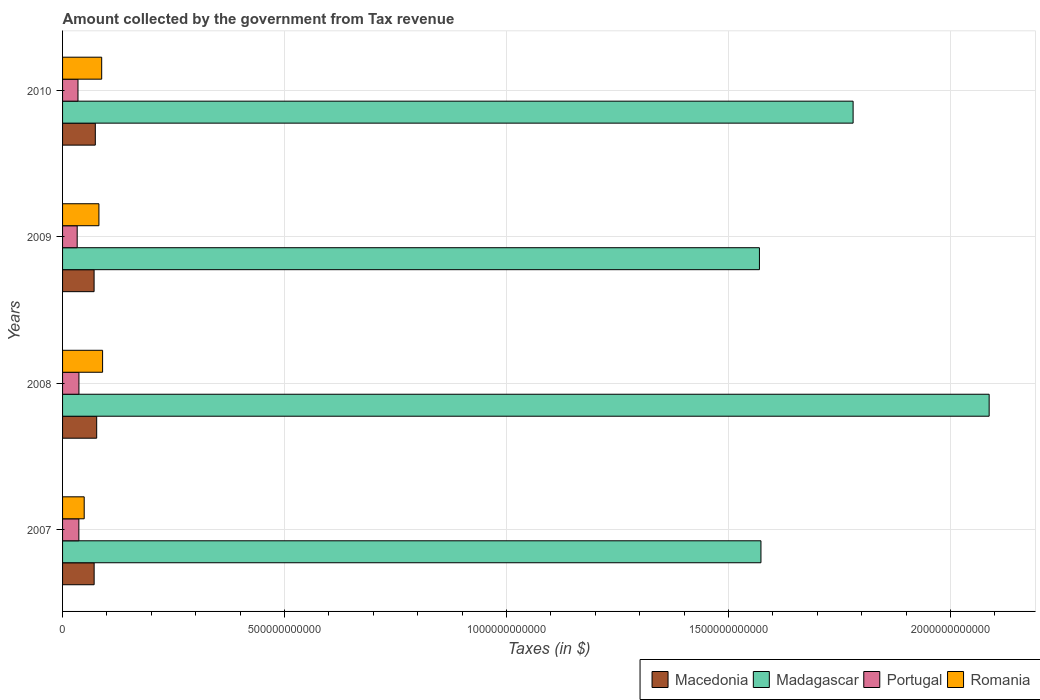How many groups of bars are there?
Give a very brief answer. 4. What is the label of the 3rd group of bars from the top?
Provide a succinct answer. 2008. In how many cases, is the number of bars for a given year not equal to the number of legend labels?
Offer a very short reply. 0. What is the amount collected by the government from tax revenue in Madagascar in 2010?
Your response must be concise. 1.78e+12. Across all years, what is the maximum amount collected by the government from tax revenue in Macedonia?
Provide a succinct answer. 7.69e+1. Across all years, what is the minimum amount collected by the government from tax revenue in Macedonia?
Give a very brief answer. 7.10e+1. In which year was the amount collected by the government from tax revenue in Madagascar maximum?
Your response must be concise. 2008. In which year was the amount collected by the government from tax revenue in Madagascar minimum?
Your answer should be very brief. 2009. What is the total amount collected by the government from tax revenue in Macedonia in the graph?
Offer a very short reply. 2.93e+11. What is the difference between the amount collected by the government from tax revenue in Romania in 2009 and that in 2010?
Your response must be concise. -6.22e+09. What is the difference between the amount collected by the government from tax revenue in Macedonia in 2010 and the amount collected by the government from tax revenue in Madagascar in 2009?
Your answer should be very brief. -1.50e+12. What is the average amount collected by the government from tax revenue in Portugal per year?
Your answer should be very brief. 3.53e+1. In the year 2010, what is the difference between the amount collected by the government from tax revenue in Romania and amount collected by the government from tax revenue in Macedonia?
Your answer should be very brief. 1.44e+1. In how many years, is the amount collected by the government from tax revenue in Romania greater than 100000000000 $?
Your response must be concise. 0. What is the ratio of the amount collected by the government from tax revenue in Macedonia in 2007 to that in 2009?
Give a very brief answer. 1. What is the difference between the highest and the second highest amount collected by the government from tax revenue in Madagascar?
Ensure brevity in your answer.  3.06e+11. What is the difference between the highest and the lowest amount collected by the government from tax revenue in Romania?
Provide a short and direct response. 4.14e+1. What does the 2nd bar from the top in 2007 represents?
Offer a terse response. Portugal. What does the 2nd bar from the bottom in 2010 represents?
Provide a short and direct response. Madagascar. Is it the case that in every year, the sum of the amount collected by the government from tax revenue in Portugal and amount collected by the government from tax revenue in Macedonia is greater than the amount collected by the government from tax revenue in Madagascar?
Ensure brevity in your answer.  No. Are all the bars in the graph horizontal?
Your answer should be very brief. Yes. What is the difference between two consecutive major ticks on the X-axis?
Ensure brevity in your answer.  5.00e+11. Are the values on the major ticks of X-axis written in scientific E-notation?
Your answer should be very brief. No. Does the graph contain grids?
Offer a very short reply. Yes. Where does the legend appear in the graph?
Your answer should be very brief. Bottom right. How are the legend labels stacked?
Provide a short and direct response. Horizontal. What is the title of the graph?
Make the answer very short. Amount collected by the government from Tax revenue. What is the label or title of the X-axis?
Your answer should be compact. Taxes (in $). What is the Taxes (in $) of Macedonia in 2007?
Your answer should be very brief. 7.11e+1. What is the Taxes (in $) of Madagascar in 2007?
Give a very brief answer. 1.57e+12. What is the Taxes (in $) in Portugal in 2007?
Your answer should be compact. 3.67e+1. What is the Taxes (in $) of Romania in 2007?
Ensure brevity in your answer.  4.88e+1. What is the Taxes (in $) in Macedonia in 2008?
Give a very brief answer. 7.69e+1. What is the Taxes (in $) of Madagascar in 2008?
Your answer should be very brief. 2.09e+12. What is the Taxes (in $) in Portugal in 2008?
Your response must be concise. 3.69e+1. What is the Taxes (in $) in Romania in 2008?
Make the answer very short. 9.01e+1. What is the Taxes (in $) in Macedonia in 2009?
Ensure brevity in your answer.  7.10e+1. What is the Taxes (in $) in Madagascar in 2009?
Offer a terse response. 1.57e+12. What is the Taxes (in $) in Portugal in 2009?
Offer a terse response. 3.30e+1. What is the Taxes (in $) in Romania in 2009?
Offer a very short reply. 8.19e+1. What is the Taxes (in $) of Macedonia in 2010?
Make the answer very short. 7.38e+1. What is the Taxes (in $) in Madagascar in 2010?
Ensure brevity in your answer.  1.78e+12. What is the Taxes (in $) in Portugal in 2010?
Provide a short and direct response. 3.47e+1. What is the Taxes (in $) in Romania in 2010?
Offer a very short reply. 8.81e+1. Across all years, what is the maximum Taxes (in $) in Macedonia?
Offer a very short reply. 7.69e+1. Across all years, what is the maximum Taxes (in $) in Madagascar?
Provide a short and direct response. 2.09e+12. Across all years, what is the maximum Taxes (in $) of Portugal?
Make the answer very short. 3.69e+1. Across all years, what is the maximum Taxes (in $) of Romania?
Your answer should be very brief. 9.01e+1. Across all years, what is the minimum Taxes (in $) in Macedonia?
Give a very brief answer. 7.10e+1. Across all years, what is the minimum Taxes (in $) in Madagascar?
Provide a succinct answer. 1.57e+12. Across all years, what is the minimum Taxes (in $) of Portugal?
Ensure brevity in your answer.  3.30e+1. Across all years, what is the minimum Taxes (in $) in Romania?
Provide a short and direct response. 4.88e+1. What is the total Taxes (in $) in Macedonia in the graph?
Make the answer very short. 2.93e+11. What is the total Taxes (in $) in Madagascar in the graph?
Provide a succinct answer. 7.01e+12. What is the total Taxes (in $) in Portugal in the graph?
Give a very brief answer. 1.41e+11. What is the total Taxes (in $) in Romania in the graph?
Your answer should be very brief. 3.09e+11. What is the difference between the Taxes (in $) of Macedonia in 2007 and that in 2008?
Provide a short and direct response. -5.73e+09. What is the difference between the Taxes (in $) in Madagascar in 2007 and that in 2008?
Your answer should be very brief. -5.14e+11. What is the difference between the Taxes (in $) of Portugal in 2007 and that in 2008?
Provide a short and direct response. -1.94e+08. What is the difference between the Taxes (in $) in Romania in 2007 and that in 2008?
Offer a terse response. -4.14e+1. What is the difference between the Taxes (in $) of Macedonia in 2007 and that in 2009?
Offer a very short reply. 1.05e+08. What is the difference between the Taxes (in $) in Madagascar in 2007 and that in 2009?
Your response must be concise. 3.39e+09. What is the difference between the Taxes (in $) in Portugal in 2007 and that in 2009?
Your answer should be very brief. 3.73e+09. What is the difference between the Taxes (in $) of Romania in 2007 and that in 2009?
Provide a short and direct response. -3.31e+1. What is the difference between the Taxes (in $) in Macedonia in 2007 and that in 2010?
Make the answer very short. -2.63e+09. What is the difference between the Taxes (in $) of Madagascar in 2007 and that in 2010?
Your answer should be very brief. -2.08e+11. What is the difference between the Taxes (in $) of Portugal in 2007 and that in 2010?
Offer a terse response. 1.97e+09. What is the difference between the Taxes (in $) in Romania in 2007 and that in 2010?
Your answer should be compact. -3.94e+1. What is the difference between the Taxes (in $) of Macedonia in 2008 and that in 2009?
Your response must be concise. 5.83e+09. What is the difference between the Taxes (in $) in Madagascar in 2008 and that in 2009?
Ensure brevity in your answer.  5.17e+11. What is the difference between the Taxes (in $) of Portugal in 2008 and that in 2009?
Your answer should be very brief. 3.93e+09. What is the difference between the Taxes (in $) in Romania in 2008 and that in 2009?
Give a very brief answer. 8.26e+09. What is the difference between the Taxes (in $) in Macedonia in 2008 and that in 2010?
Keep it short and to the point. 3.10e+09. What is the difference between the Taxes (in $) of Madagascar in 2008 and that in 2010?
Your response must be concise. 3.06e+11. What is the difference between the Taxes (in $) of Portugal in 2008 and that in 2010?
Give a very brief answer. 2.16e+09. What is the difference between the Taxes (in $) in Romania in 2008 and that in 2010?
Your answer should be compact. 2.04e+09. What is the difference between the Taxes (in $) of Macedonia in 2009 and that in 2010?
Your answer should be compact. -2.73e+09. What is the difference between the Taxes (in $) of Madagascar in 2009 and that in 2010?
Offer a very short reply. -2.11e+11. What is the difference between the Taxes (in $) of Portugal in 2009 and that in 2010?
Your answer should be compact. -1.77e+09. What is the difference between the Taxes (in $) of Romania in 2009 and that in 2010?
Make the answer very short. -6.22e+09. What is the difference between the Taxes (in $) of Macedonia in 2007 and the Taxes (in $) of Madagascar in 2008?
Keep it short and to the point. -2.02e+12. What is the difference between the Taxes (in $) in Macedonia in 2007 and the Taxes (in $) in Portugal in 2008?
Keep it short and to the point. 3.42e+1. What is the difference between the Taxes (in $) in Macedonia in 2007 and the Taxes (in $) in Romania in 2008?
Provide a succinct answer. -1.90e+1. What is the difference between the Taxes (in $) in Madagascar in 2007 and the Taxes (in $) in Portugal in 2008?
Provide a short and direct response. 1.54e+12. What is the difference between the Taxes (in $) in Madagascar in 2007 and the Taxes (in $) in Romania in 2008?
Ensure brevity in your answer.  1.48e+12. What is the difference between the Taxes (in $) of Portugal in 2007 and the Taxes (in $) of Romania in 2008?
Ensure brevity in your answer.  -5.35e+1. What is the difference between the Taxes (in $) of Macedonia in 2007 and the Taxes (in $) of Madagascar in 2009?
Make the answer very short. -1.50e+12. What is the difference between the Taxes (in $) in Macedonia in 2007 and the Taxes (in $) in Portugal in 2009?
Your answer should be very brief. 3.82e+1. What is the difference between the Taxes (in $) in Macedonia in 2007 and the Taxes (in $) in Romania in 2009?
Offer a very short reply. -1.08e+1. What is the difference between the Taxes (in $) of Madagascar in 2007 and the Taxes (in $) of Portugal in 2009?
Offer a very short reply. 1.54e+12. What is the difference between the Taxes (in $) of Madagascar in 2007 and the Taxes (in $) of Romania in 2009?
Offer a very short reply. 1.49e+12. What is the difference between the Taxes (in $) of Portugal in 2007 and the Taxes (in $) of Romania in 2009?
Your answer should be very brief. -4.52e+1. What is the difference between the Taxes (in $) of Macedonia in 2007 and the Taxes (in $) of Madagascar in 2010?
Keep it short and to the point. -1.71e+12. What is the difference between the Taxes (in $) in Macedonia in 2007 and the Taxes (in $) in Portugal in 2010?
Offer a terse response. 3.64e+1. What is the difference between the Taxes (in $) of Macedonia in 2007 and the Taxes (in $) of Romania in 2010?
Your answer should be compact. -1.70e+1. What is the difference between the Taxes (in $) in Madagascar in 2007 and the Taxes (in $) in Portugal in 2010?
Your answer should be compact. 1.54e+12. What is the difference between the Taxes (in $) in Madagascar in 2007 and the Taxes (in $) in Romania in 2010?
Your answer should be compact. 1.49e+12. What is the difference between the Taxes (in $) in Portugal in 2007 and the Taxes (in $) in Romania in 2010?
Provide a succinct answer. -5.14e+1. What is the difference between the Taxes (in $) in Macedonia in 2008 and the Taxes (in $) in Madagascar in 2009?
Your answer should be compact. -1.49e+12. What is the difference between the Taxes (in $) of Macedonia in 2008 and the Taxes (in $) of Portugal in 2009?
Offer a very short reply. 4.39e+1. What is the difference between the Taxes (in $) of Macedonia in 2008 and the Taxes (in $) of Romania in 2009?
Provide a succinct answer. -5.03e+09. What is the difference between the Taxes (in $) in Madagascar in 2008 and the Taxes (in $) in Portugal in 2009?
Give a very brief answer. 2.05e+12. What is the difference between the Taxes (in $) of Madagascar in 2008 and the Taxes (in $) of Romania in 2009?
Your answer should be very brief. 2.01e+12. What is the difference between the Taxes (in $) of Portugal in 2008 and the Taxes (in $) of Romania in 2009?
Provide a short and direct response. -4.50e+1. What is the difference between the Taxes (in $) in Macedonia in 2008 and the Taxes (in $) in Madagascar in 2010?
Provide a succinct answer. -1.70e+12. What is the difference between the Taxes (in $) of Macedonia in 2008 and the Taxes (in $) of Portugal in 2010?
Give a very brief answer. 4.21e+1. What is the difference between the Taxes (in $) of Macedonia in 2008 and the Taxes (in $) of Romania in 2010?
Offer a very short reply. -1.13e+1. What is the difference between the Taxes (in $) of Madagascar in 2008 and the Taxes (in $) of Portugal in 2010?
Give a very brief answer. 2.05e+12. What is the difference between the Taxes (in $) of Madagascar in 2008 and the Taxes (in $) of Romania in 2010?
Your answer should be very brief. 2.00e+12. What is the difference between the Taxes (in $) of Portugal in 2008 and the Taxes (in $) of Romania in 2010?
Provide a short and direct response. -5.12e+1. What is the difference between the Taxes (in $) in Macedonia in 2009 and the Taxes (in $) in Madagascar in 2010?
Offer a terse response. -1.71e+12. What is the difference between the Taxes (in $) of Macedonia in 2009 and the Taxes (in $) of Portugal in 2010?
Provide a succinct answer. 3.63e+1. What is the difference between the Taxes (in $) of Macedonia in 2009 and the Taxes (in $) of Romania in 2010?
Your answer should be compact. -1.71e+1. What is the difference between the Taxes (in $) of Madagascar in 2009 and the Taxes (in $) of Portugal in 2010?
Your answer should be very brief. 1.54e+12. What is the difference between the Taxes (in $) in Madagascar in 2009 and the Taxes (in $) in Romania in 2010?
Make the answer very short. 1.48e+12. What is the difference between the Taxes (in $) in Portugal in 2009 and the Taxes (in $) in Romania in 2010?
Offer a very short reply. -5.52e+1. What is the average Taxes (in $) of Macedonia per year?
Make the answer very short. 7.32e+1. What is the average Taxes (in $) in Madagascar per year?
Keep it short and to the point. 1.75e+12. What is the average Taxes (in $) of Portugal per year?
Provide a succinct answer. 3.53e+1. What is the average Taxes (in $) of Romania per year?
Make the answer very short. 7.72e+1. In the year 2007, what is the difference between the Taxes (in $) of Macedonia and Taxes (in $) of Madagascar?
Provide a short and direct response. -1.50e+12. In the year 2007, what is the difference between the Taxes (in $) in Macedonia and Taxes (in $) in Portugal?
Keep it short and to the point. 3.44e+1. In the year 2007, what is the difference between the Taxes (in $) in Macedonia and Taxes (in $) in Romania?
Ensure brevity in your answer.  2.24e+1. In the year 2007, what is the difference between the Taxes (in $) of Madagascar and Taxes (in $) of Portugal?
Make the answer very short. 1.54e+12. In the year 2007, what is the difference between the Taxes (in $) in Madagascar and Taxes (in $) in Romania?
Ensure brevity in your answer.  1.52e+12. In the year 2007, what is the difference between the Taxes (in $) in Portugal and Taxes (in $) in Romania?
Your response must be concise. -1.21e+1. In the year 2008, what is the difference between the Taxes (in $) in Macedonia and Taxes (in $) in Madagascar?
Provide a succinct answer. -2.01e+12. In the year 2008, what is the difference between the Taxes (in $) of Macedonia and Taxes (in $) of Portugal?
Keep it short and to the point. 4.00e+1. In the year 2008, what is the difference between the Taxes (in $) in Macedonia and Taxes (in $) in Romania?
Your answer should be very brief. -1.33e+1. In the year 2008, what is the difference between the Taxes (in $) of Madagascar and Taxes (in $) of Portugal?
Your answer should be very brief. 2.05e+12. In the year 2008, what is the difference between the Taxes (in $) of Madagascar and Taxes (in $) of Romania?
Make the answer very short. 2.00e+12. In the year 2008, what is the difference between the Taxes (in $) in Portugal and Taxes (in $) in Romania?
Your answer should be compact. -5.33e+1. In the year 2009, what is the difference between the Taxes (in $) in Macedonia and Taxes (in $) in Madagascar?
Offer a terse response. -1.50e+12. In the year 2009, what is the difference between the Taxes (in $) of Macedonia and Taxes (in $) of Portugal?
Give a very brief answer. 3.81e+1. In the year 2009, what is the difference between the Taxes (in $) of Macedonia and Taxes (in $) of Romania?
Offer a very short reply. -1.09e+1. In the year 2009, what is the difference between the Taxes (in $) of Madagascar and Taxes (in $) of Portugal?
Give a very brief answer. 1.54e+12. In the year 2009, what is the difference between the Taxes (in $) in Madagascar and Taxes (in $) in Romania?
Your answer should be very brief. 1.49e+12. In the year 2009, what is the difference between the Taxes (in $) in Portugal and Taxes (in $) in Romania?
Offer a terse response. -4.89e+1. In the year 2010, what is the difference between the Taxes (in $) in Macedonia and Taxes (in $) in Madagascar?
Offer a very short reply. -1.71e+12. In the year 2010, what is the difference between the Taxes (in $) in Macedonia and Taxes (in $) in Portugal?
Give a very brief answer. 3.90e+1. In the year 2010, what is the difference between the Taxes (in $) in Macedonia and Taxes (in $) in Romania?
Offer a very short reply. -1.44e+1. In the year 2010, what is the difference between the Taxes (in $) of Madagascar and Taxes (in $) of Portugal?
Provide a short and direct response. 1.75e+12. In the year 2010, what is the difference between the Taxes (in $) in Madagascar and Taxes (in $) in Romania?
Ensure brevity in your answer.  1.69e+12. In the year 2010, what is the difference between the Taxes (in $) of Portugal and Taxes (in $) of Romania?
Keep it short and to the point. -5.34e+1. What is the ratio of the Taxes (in $) of Macedonia in 2007 to that in 2008?
Give a very brief answer. 0.93. What is the ratio of the Taxes (in $) of Madagascar in 2007 to that in 2008?
Provide a succinct answer. 0.75. What is the ratio of the Taxes (in $) in Portugal in 2007 to that in 2008?
Provide a short and direct response. 0.99. What is the ratio of the Taxes (in $) of Romania in 2007 to that in 2008?
Keep it short and to the point. 0.54. What is the ratio of the Taxes (in $) in Portugal in 2007 to that in 2009?
Ensure brevity in your answer.  1.11. What is the ratio of the Taxes (in $) of Romania in 2007 to that in 2009?
Make the answer very short. 0.6. What is the ratio of the Taxes (in $) in Macedonia in 2007 to that in 2010?
Provide a succinct answer. 0.96. What is the ratio of the Taxes (in $) of Madagascar in 2007 to that in 2010?
Provide a short and direct response. 0.88. What is the ratio of the Taxes (in $) in Portugal in 2007 to that in 2010?
Your response must be concise. 1.06. What is the ratio of the Taxes (in $) in Romania in 2007 to that in 2010?
Ensure brevity in your answer.  0.55. What is the ratio of the Taxes (in $) in Macedonia in 2008 to that in 2009?
Your response must be concise. 1.08. What is the ratio of the Taxes (in $) in Madagascar in 2008 to that in 2009?
Offer a very short reply. 1.33. What is the ratio of the Taxes (in $) of Portugal in 2008 to that in 2009?
Give a very brief answer. 1.12. What is the ratio of the Taxes (in $) of Romania in 2008 to that in 2009?
Ensure brevity in your answer.  1.1. What is the ratio of the Taxes (in $) of Macedonia in 2008 to that in 2010?
Provide a succinct answer. 1.04. What is the ratio of the Taxes (in $) of Madagascar in 2008 to that in 2010?
Ensure brevity in your answer.  1.17. What is the ratio of the Taxes (in $) in Portugal in 2008 to that in 2010?
Your response must be concise. 1.06. What is the ratio of the Taxes (in $) of Romania in 2008 to that in 2010?
Provide a short and direct response. 1.02. What is the ratio of the Taxes (in $) in Macedonia in 2009 to that in 2010?
Your answer should be very brief. 0.96. What is the ratio of the Taxes (in $) in Madagascar in 2009 to that in 2010?
Keep it short and to the point. 0.88. What is the ratio of the Taxes (in $) of Portugal in 2009 to that in 2010?
Make the answer very short. 0.95. What is the ratio of the Taxes (in $) of Romania in 2009 to that in 2010?
Your answer should be very brief. 0.93. What is the difference between the highest and the second highest Taxes (in $) in Macedonia?
Your answer should be compact. 3.10e+09. What is the difference between the highest and the second highest Taxes (in $) of Madagascar?
Provide a succinct answer. 3.06e+11. What is the difference between the highest and the second highest Taxes (in $) of Portugal?
Your answer should be compact. 1.94e+08. What is the difference between the highest and the second highest Taxes (in $) in Romania?
Offer a terse response. 2.04e+09. What is the difference between the highest and the lowest Taxes (in $) in Macedonia?
Offer a terse response. 5.83e+09. What is the difference between the highest and the lowest Taxes (in $) of Madagascar?
Give a very brief answer. 5.17e+11. What is the difference between the highest and the lowest Taxes (in $) in Portugal?
Give a very brief answer. 3.93e+09. What is the difference between the highest and the lowest Taxes (in $) of Romania?
Ensure brevity in your answer.  4.14e+1. 